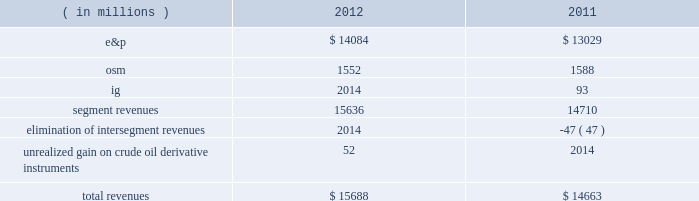Key operating and financial activities significant operating and financial activities during 2012 include : 2022 net proved reserve additions for the e&p and osm segments combined of 389 mmboe , for a 226 percent reserve replacement 2022 increased proved liquid hydrocarbon and synthetic crude oil reserves by 316 mmbbls , for a reserve replacement of 268 percent for these commodities 2022 recorded more than 95 percent average operational availability for operated e&p assets 2022 increased e&p net sales volumes , excluding libya , by 8 percent 2022 eagle ford shale average net sales volumes of 65 mboed for december 2012 , a fourfold increase over december 2011 2022 bakken shale average net sales volumes of 29 mboed , a 71 percent increase over last year 2022 resumed sales from libya and reached pre-conflict production levels 2022 international liquid hydrocarbon sales volumes , for which average realizations have exceeded wti , were 62 percent of net e&p liquid hydrocarbon sales 2022 closed $ 1 billion of acquisitions in the core of the eagle ford shale 2022 assumed operatorship of the vilje field located offshore norway 2022 signed agreements for new exploration positions in e.g. , gabon , kenya and ethiopia 2022 issued $ 1 billion of 3-year senior notes at 0.9 percent interest and $ 1 billion of 10-year senior notes at 2.8 percent interest some significant 2013 activities through february 22 , 2013 include : 2022 closed sale of our alaska assets in january 2013 2022 closed sale of our interest in the neptune gas plant in february 2013 consolidated results of operations : 2012 compared to 2011 consolidated income before income taxes was 38 percent higher in 2012 than consolidated income from continuing operations before income taxes were in 2011 , largely due to higher liquid hydrocarbon sales volumes in our e&p segment , partially offset by lower earnings from our osm and ig segments .
The 7 percent decrease in income from continuing operations included lower earnings in the u.k .
And e.g. , partially offset by higher earnings in libya .
Also , in 2011 we were not in an excess foreign tax credit position for the entire year as we were in 2012 .
The effective income tax rate for continuing operations was 74 percent in 2012 compared to 61 percent in 2011 .
Revenues are summarized in the table: .
E&p segment revenues increased $ 1055 million from 2011 to 2012 , primarily due to higher average liquid hydrocarbon sales volumes .
E&p segment revenues included a net realized gain on crude oil derivative instruments of $ 15 million in 2012 while the impact of derivatives was not significant in 2011 .
See item 8 .
Financial statements and supplementary data 2013 note 16 to the consolidated financial statement for more information about our crude oil derivative instruments .
Included in our e&p segment are supply optimization activities which include the purchase of commodities from third parties for resale .
See the cost of revenues discussion as revenues from supply optimization approximate the related costs .
Supply optimization serves to aggregate volumes in order to satisfy transportation commitments and to achieve flexibility within product .
What was the change in the effective income tax rate for continuing operations between in 2012 compared to 2011? 
Computations: (74 - 61)
Answer: 13.0. 